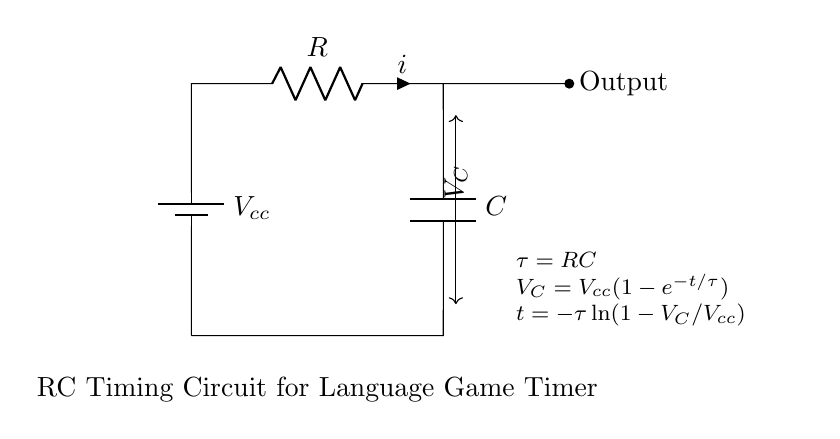What is the value of the resistor? The resistor value is denoted as R, which is a generic label and not specified in the diagram.
Answer: R What does C represent in the circuit? C represents the capacitance in the circuit, which is a component that stores electrical energy.
Answer: Capacitance What is the formula for the time constant? The time constant is calculated using the formula τ = RC, showing how much time it takes for the circuit to charge or discharge.
Answer: RC What does V_C represent in this circuit? V_C is the voltage across the capacitor, which changes over time as the capacitor charges through the resistor.
Answer: Voltage across the capacitor If V_cc is 10 volts, what will V_C be at time τ? At time τ, V_C will equal approximately 6.32 volts, calculated from the formula V_C = V_cc(1 - e^(-1)), where e is the base of the natural logarithm.
Answer: 6.32 volts How is the output taken in this RC circuit? The output is taken directly from the node connected to the capacitor, indicating the voltage that develops across it.
Answer: Voltage across the capacitor What happens to V_C as time increases? As time increases, V_C approaches V_cc asymptotically, meaning it gets closer to V_cc but never fully reaches it within finite time.
Answer: Approaches V_cc 